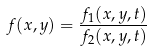<formula> <loc_0><loc_0><loc_500><loc_500>f ( x , y ) = \frac { f _ { 1 } ( x , y , t ) } { f _ { 2 } ( x , y , t ) }</formula> 